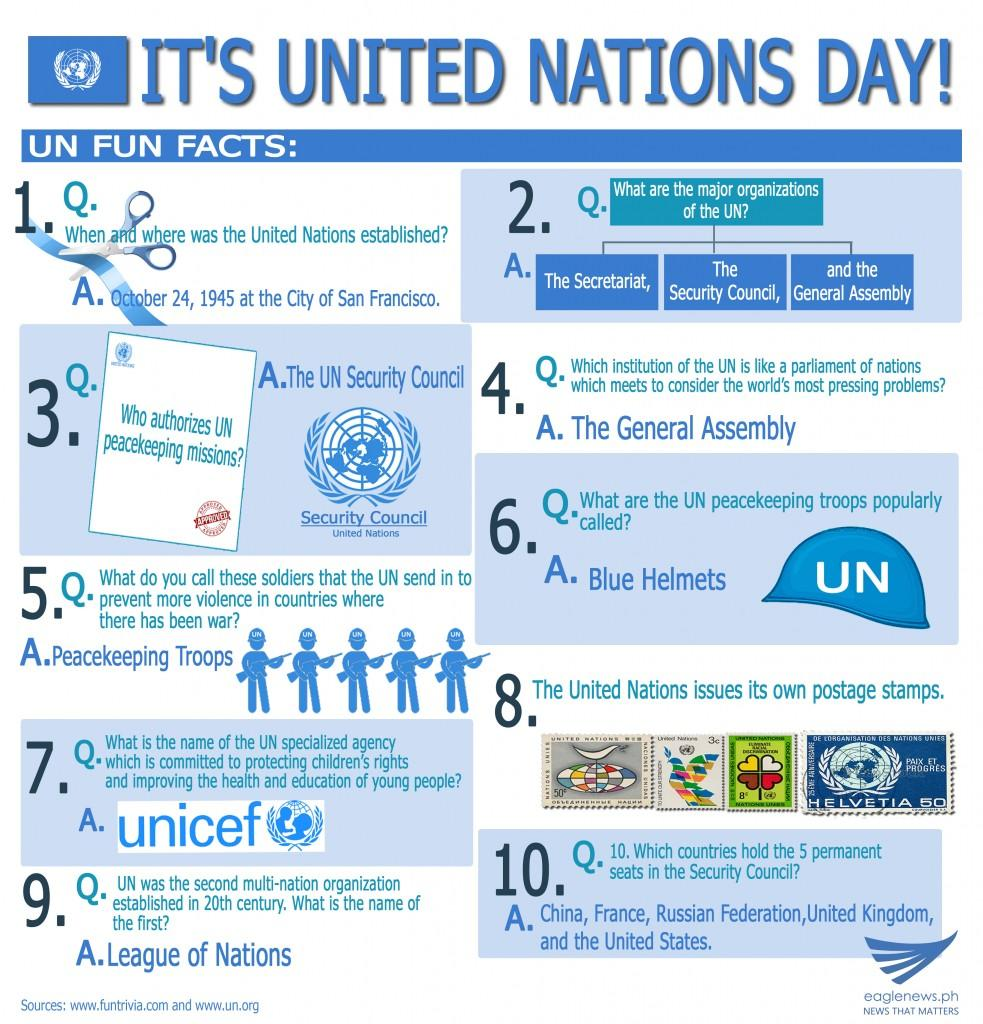Outline some significant characteristics in this image. The United Nations Security Council controls peacekeeping. The United Nations has three major organizations under its umbrella. 